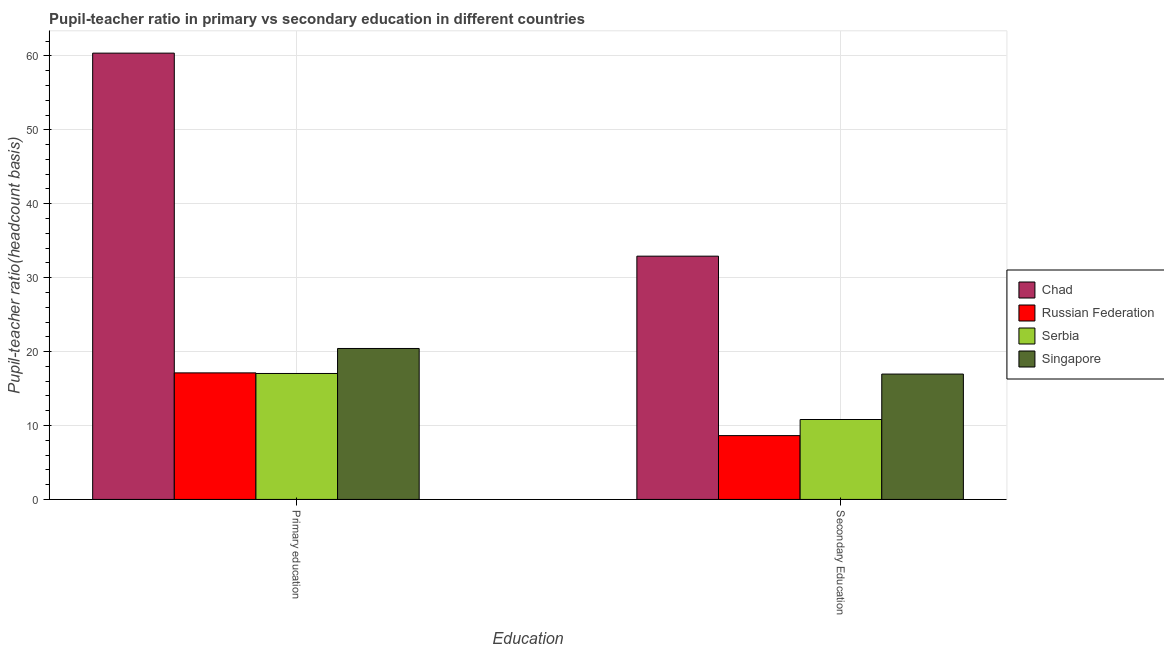How many different coloured bars are there?
Provide a succinct answer. 4. Are the number of bars on each tick of the X-axis equal?
Offer a very short reply. Yes. How many bars are there on the 2nd tick from the left?
Ensure brevity in your answer.  4. How many bars are there on the 2nd tick from the right?
Provide a succinct answer. 4. What is the pupil-teacher ratio in primary education in Serbia?
Make the answer very short. 17.04. Across all countries, what is the maximum pupil-teacher ratio in primary education?
Your answer should be compact. 60.38. Across all countries, what is the minimum pupil teacher ratio on secondary education?
Ensure brevity in your answer.  8.63. In which country was the pupil-teacher ratio in primary education maximum?
Keep it short and to the point. Chad. In which country was the pupil teacher ratio on secondary education minimum?
Provide a short and direct response. Russian Federation. What is the total pupil teacher ratio on secondary education in the graph?
Your response must be concise. 69.32. What is the difference between the pupil-teacher ratio in primary education in Russian Federation and that in Singapore?
Your answer should be compact. -3.3. What is the difference between the pupil-teacher ratio in primary education in Singapore and the pupil teacher ratio on secondary education in Russian Federation?
Provide a short and direct response. 11.79. What is the average pupil-teacher ratio in primary education per country?
Make the answer very short. 28.74. What is the difference between the pupil-teacher ratio in primary education and pupil teacher ratio on secondary education in Chad?
Make the answer very short. 27.47. What is the ratio of the pupil-teacher ratio in primary education in Chad to that in Serbia?
Your response must be concise. 3.54. Is the pupil teacher ratio on secondary education in Serbia less than that in Chad?
Give a very brief answer. Yes. What does the 4th bar from the left in Primary education represents?
Give a very brief answer. Singapore. What does the 4th bar from the right in Secondary Education represents?
Ensure brevity in your answer.  Chad. How many countries are there in the graph?
Give a very brief answer. 4. Does the graph contain grids?
Make the answer very short. Yes. How are the legend labels stacked?
Your answer should be very brief. Vertical. What is the title of the graph?
Your response must be concise. Pupil-teacher ratio in primary vs secondary education in different countries. What is the label or title of the X-axis?
Give a very brief answer. Education. What is the label or title of the Y-axis?
Offer a very short reply. Pupil-teacher ratio(headcount basis). What is the Pupil-teacher ratio(headcount basis) of Chad in Primary education?
Your answer should be compact. 60.38. What is the Pupil-teacher ratio(headcount basis) of Russian Federation in Primary education?
Your answer should be compact. 17.12. What is the Pupil-teacher ratio(headcount basis) of Serbia in Primary education?
Offer a terse response. 17.04. What is the Pupil-teacher ratio(headcount basis) of Singapore in Primary education?
Your answer should be very brief. 20.42. What is the Pupil-teacher ratio(headcount basis) of Chad in Secondary Education?
Provide a succinct answer. 32.91. What is the Pupil-teacher ratio(headcount basis) in Russian Federation in Secondary Education?
Your answer should be compact. 8.63. What is the Pupil-teacher ratio(headcount basis) of Serbia in Secondary Education?
Your answer should be very brief. 10.81. What is the Pupil-teacher ratio(headcount basis) in Singapore in Secondary Education?
Keep it short and to the point. 16.96. Across all Education, what is the maximum Pupil-teacher ratio(headcount basis) in Chad?
Your answer should be very brief. 60.38. Across all Education, what is the maximum Pupil-teacher ratio(headcount basis) in Russian Federation?
Offer a very short reply. 17.12. Across all Education, what is the maximum Pupil-teacher ratio(headcount basis) of Serbia?
Provide a succinct answer. 17.04. Across all Education, what is the maximum Pupil-teacher ratio(headcount basis) in Singapore?
Keep it short and to the point. 20.42. Across all Education, what is the minimum Pupil-teacher ratio(headcount basis) of Chad?
Make the answer very short. 32.91. Across all Education, what is the minimum Pupil-teacher ratio(headcount basis) in Russian Federation?
Your response must be concise. 8.63. Across all Education, what is the minimum Pupil-teacher ratio(headcount basis) in Serbia?
Make the answer very short. 10.81. Across all Education, what is the minimum Pupil-teacher ratio(headcount basis) in Singapore?
Keep it short and to the point. 16.96. What is the total Pupil-teacher ratio(headcount basis) in Chad in the graph?
Make the answer very short. 93.29. What is the total Pupil-teacher ratio(headcount basis) of Russian Federation in the graph?
Ensure brevity in your answer.  25.75. What is the total Pupil-teacher ratio(headcount basis) in Serbia in the graph?
Your response must be concise. 27.85. What is the total Pupil-teacher ratio(headcount basis) of Singapore in the graph?
Offer a very short reply. 37.38. What is the difference between the Pupil-teacher ratio(headcount basis) in Chad in Primary education and that in Secondary Education?
Your answer should be very brief. 27.47. What is the difference between the Pupil-teacher ratio(headcount basis) in Russian Federation in Primary education and that in Secondary Education?
Your response must be concise. 8.49. What is the difference between the Pupil-teacher ratio(headcount basis) in Serbia in Primary education and that in Secondary Education?
Keep it short and to the point. 6.23. What is the difference between the Pupil-teacher ratio(headcount basis) in Singapore in Primary education and that in Secondary Education?
Provide a succinct answer. 3.46. What is the difference between the Pupil-teacher ratio(headcount basis) of Chad in Primary education and the Pupil-teacher ratio(headcount basis) of Russian Federation in Secondary Education?
Your answer should be very brief. 51.75. What is the difference between the Pupil-teacher ratio(headcount basis) of Chad in Primary education and the Pupil-teacher ratio(headcount basis) of Serbia in Secondary Education?
Offer a terse response. 49.57. What is the difference between the Pupil-teacher ratio(headcount basis) in Chad in Primary education and the Pupil-teacher ratio(headcount basis) in Singapore in Secondary Education?
Keep it short and to the point. 43.42. What is the difference between the Pupil-teacher ratio(headcount basis) of Russian Federation in Primary education and the Pupil-teacher ratio(headcount basis) of Serbia in Secondary Education?
Offer a very short reply. 6.31. What is the difference between the Pupil-teacher ratio(headcount basis) in Russian Federation in Primary education and the Pupil-teacher ratio(headcount basis) in Singapore in Secondary Education?
Your answer should be compact. 0.16. What is the difference between the Pupil-teacher ratio(headcount basis) of Serbia in Primary education and the Pupil-teacher ratio(headcount basis) of Singapore in Secondary Education?
Keep it short and to the point. 0.08. What is the average Pupil-teacher ratio(headcount basis) in Chad per Education?
Your response must be concise. 46.65. What is the average Pupil-teacher ratio(headcount basis) of Russian Federation per Education?
Make the answer very short. 12.88. What is the average Pupil-teacher ratio(headcount basis) of Serbia per Education?
Give a very brief answer. 13.93. What is the average Pupil-teacher ratio(headcount basis) of Singapore per Education?
Your answer should be very brief. 18.69. What is the difference between the Pupil-teacher ratio(headcount basis) of Chad and Pupil-teacher ratio(headcount basis) of Russian Federation in Primary education?
Ensure brevity in your answer.  43.26. What is the difference between the Pupil-teacher ratio(headcount basis) of Chad and Pupil-teacher ratio(headcount basis) of Serbia in Primary education?
Offer a very short reply. 43.34. What is the difference between the Pupil-teacher ratio(headcount basis) in Chad and Pupil-teacher ratio(headcount basis) in Singapore in Primary education?
Your answer should be very brief. 39.96. What is the difference between the Pupil-teacher ratio(headcount basis) in Russian Federation and Pupil-teacher ratio(headcount basis) in Serbia in Primary education?
Offer a very short reply. 0.08. What is the difference between the Pupil-teacher ratio(headcount basis) in Russian Federation and Pupil-teacher ratio(headcount basis) in Singapore in Primary education?
Make the answer very short. -3.3. What is the difference between the Pupil-teacher ratio(headcount basis) of Serbia and Pupil-teacher ratio(headcount basis) of Singapore in Primary education?
Your answer should be compact. -3.38. What is the difference between the Pupil-teacher ratio(headcount basis) of Chad and Pupil-teacher ratio(headcount basis) of Russian Federation in Secondary Education?
Ensure brevity in your answer.  24.28. What is the difference between the Pupil-teacher ratio(headcount basis) in Chad and Pupil-teacher ratio(headcount basis) in Serbia in Secondary Education?
Your answer should be compact. 22.1. What is the difference between the Pupil-teacher ratio(headcount basis) of Chad and Pupil-teacher ratio(headcount basis) of Singapore in Secondary Education?
Offer a very short reply. 15.95. What is the difference between the Pupil-teacher ratio(headcount basis) of Russian Federation and Pupil-teacher ratio(headcount basis) of Serbia in Secondary Education?
Give a very brief answer. -2.18. What is the difference between the Pupil-teacher ratio(headcount basis) of Russian Federation and Pupil-teacher ratio(headcount basis) of Singapore in Secondary Education?
Provide a short and direct response. -8.33. What is the difference between the Pupil-teacher ratio(headcount basis) of Serbia and Pupil-teacher ratio(headcount basis) of Singapore in Secondary Education?
Make the answer very short. -6.15. What is the ratio of the Pupil-teacher ratio(headcount basis) in Chad in Primary education to that in Secondary Education?
Keep it short and to the point. 1.83. What is the ratio of the Pupil-teacher ratio(headcount basis) in Russian Federation in Primary education to that in Secondary Education?
Keep it short and to the point. 1.98. What is the ratio of the Pupil-teacher ratio(headcount basis) in Serbia in Primary education to that in Secondary Education?
Offer a very short reply. 1.58. What is the ratio of the Pupil-teacher ratio(headcount basis) of Singapore in Primary education to that in Secondary Education?
Offer a very short reply. 1.2. What is the difference between the highest and the second highest Pupil-teacher ratio(headcount basis) in Chad?
Your answer should be compact. 27.47. What is the difference between the highest and the second highest Pupil-teacher ratio(headcount basis) in Russian Federation?
Provide a short and direct response. 8.49. What is the difference between the highest and the second highest Pupil-teacher ratio(headcount basis) of Serbia?
Give a very brief answer. 6.23. What is the difference between the highest and the second highest Pupil-teacher ratio(headcount basis) of Singapore?
Give a very brief answer. 3.46. What is the difference between the highest and the lowest Pupil-teacher ratio(headcount basis) in Chad?
Provide a short and direct response. 27.47. What is the difference between the highest and the lowest Pupil-teacher ratio(headcount basis) in Russian Federation?
Your answer should be compact. 8.49. What is the difference between the highest and the lowest Pupil-teacher ratio(headcount basis) of Serbia?
Provide a short and direct response. 6.23. What is the difference between the highest and the lowest Pupil-teacher ratio(headcount basis) in Singapore?
Offer a terse response. 3.46. 